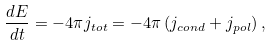Convert formula to latex. <formula><loc_0><loc_0><loc_500><loc_500>\frac { d E } { d t } = - 4 \pi j _ { t o t } = - 4 \pi \left ( j _ { c o n d } + j _ { p o l } \right ) ,</formula> 